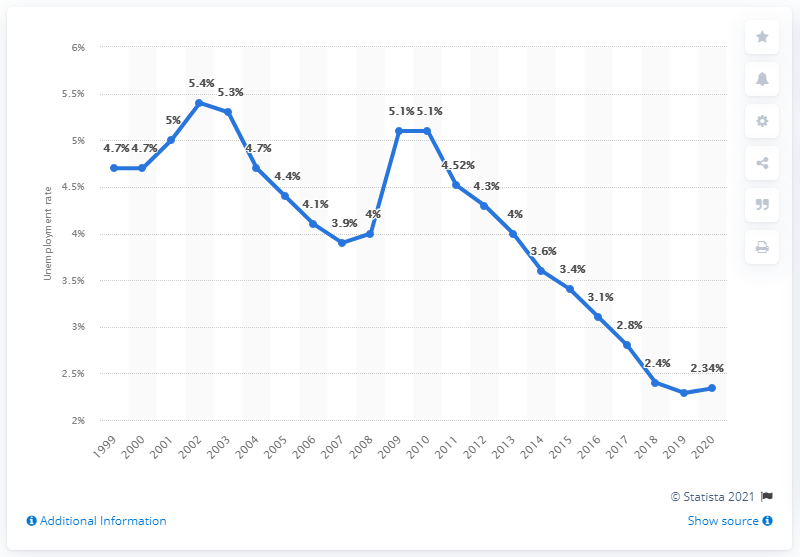Indicate a few pertinent items in this graphic. According to statistics from 2010, the unemployment rate in Japan was 5.1%. According to recent data, the unemployment rate in Japan as of 2020 was 2.34%. 